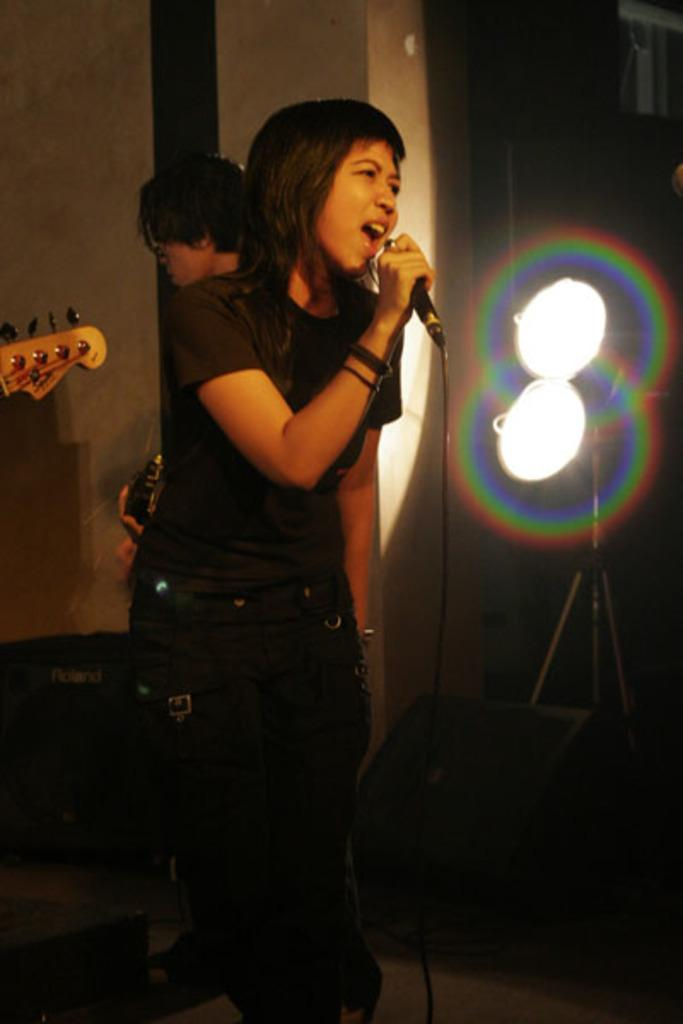What is the woman in the image doing? The woman is standing on the floor and holding a microphone. Can you describe the person in the background? There is a person standing at the back in the image. What can be seen in the image that might provide illumination? There are lights visible in the image. What type of kite is the woman flying in the image? There is no kite present in the image; the woman is holding a microphone. Can you recite the verse that the woman is singing in the image? There is no indication that the woman is singing in the image, and no lyrics are provided. 